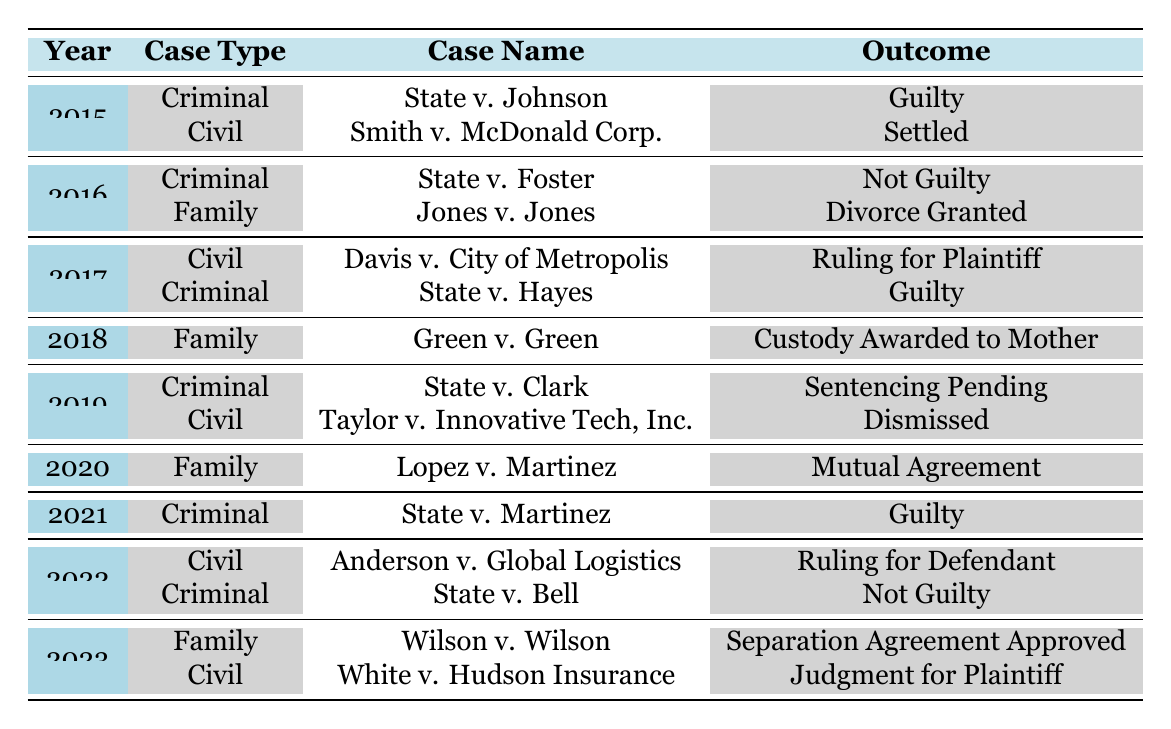What was the outcome for the case "State v. Johnson"? The table shows that the outcome for "State v. Johnson" is specified under the 2015 row in the Criminal case type section. It clearly states the outcome is "Guilty".
Answer: Guilty How many cases were settled in 2015? In 2015, there are two cases listed: "State v. Johnson" with a Guilty outcome, and "Smith v. McDonald Corp." which was settled. So, only one case was settled in that year.
Answer: 1 In which year did "State v. Martinez" occur, and what was its outcome? By looking at the Crimes row for 2021, "State v. Martinez" occurred in 2021, and its outcome was "Guilty".
Answer: 2021, Guilty What was the outcome of the family case in 2018? The table lists the "Green v. Green" case under the Family type for 2018, and the outcome given for that case is "Custody Awarded to Mother".
Answer: Custody Awarded to Mother Did any case in 2022 result in a "Ruling for Plaintiff"? Examining the year 2022 in the Civil cases section, the only listed case outcome is "Ruling for Defendant", so the answer is no.
Answer: No What is the total number of criminal cases listed over the years? By counting each instance of the Criminal case type in the table, there are a total of 6 cases: State v. Johnson, State v. Foster, State v. Hayes, State v. Clark, State v. Martinez, and State v. Bell.
Answer: 6 Which case had a "Sentencing Pending" outcome and in what year? The case "State v. Clark" listed under the Criminal case type shows it has a "Sentencing Pending" outcome, and this is found in the year 2019.
Answer: State v. Clark, 2019 What percentage of outcomes were "Guilty" in Criminal cases? In the Criminal cases, the outcomes were Guilty (4 times), Not Guilty (2 times), and Sentencing Pending (1 time), which makes a total of 7 cases. The percentage is (4/7) * 100 ≈ 57.14%.
Answer: 57.14% How many years had a Criminal case outcome of "Not Guilty"? The Criminal cases' outcomes include "Not Guilty" in the years 2016 and 2022, giving us a count of 2 years.
Answer: 2 Was the "Smith v. McDonald Corp." case decided in favor of the plaintiff? The table indicates that the outcome of "Smith v. McDonald Corp." was "Settled", which doesn't specify a favor, so the outcome cannot be definitively determined as in favor of the plaintiff.
Answer: No 